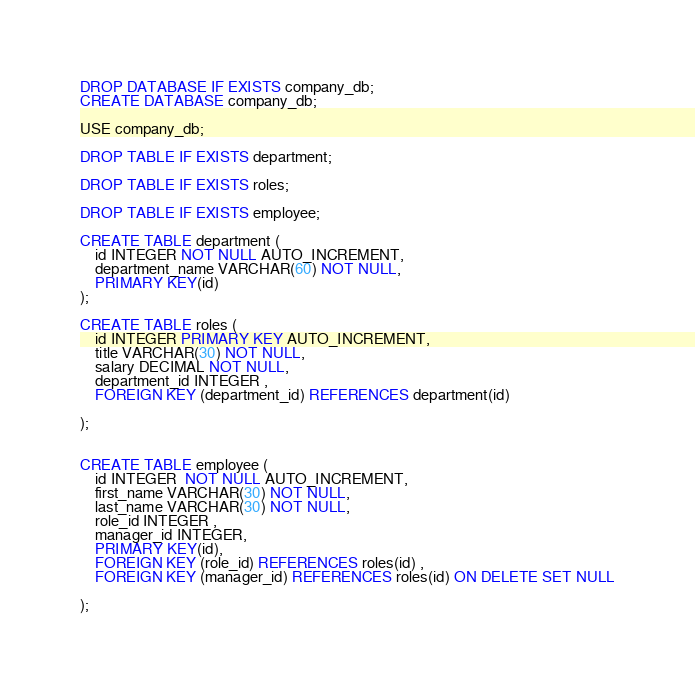Convert code to text. <code><loc_0><loc_0><loc_500><loc_500><_SQL_>DROP DATABASE IF EXISTS company_db;
CREATE DATABASE company_db;

USE company_db;

DROP TABLE IF EXISTS department;

DROP TABLE IF EXISTS roles;

DROP TABLE IF EXISTS employee;

CREATE TABLE department (
    id INTEGER NOT NULL AUTO_INCREMENT,
    department_name VARCHAR(60) NOT NULL,
    PRIMARY KEY(id)
);

CREATE TABLE roles (
    id INTEGER PRIMARY KEY AUTO_INCREMENT,
    title VARCHAR(30) NOT NULL,
    salary DECIMAL NOT NULL,
    department_id INTEGER ,
    FOREIGN KEY (department_id) REFERENCES department(id) 
    
);


CREATE TABLE employee (
    id INTEGER  NOT NULL AUTO_INCREMENT,
    first_name VARCHAR(30) NOT NULL,
    last_name VARCHAR(30) NOT NULL,
    role_id INTEGER ,
    manager_id INTEGER,
    PRIMARY KEY(id),
    FOREIGN KEY (role_id) REFERENCES roles(id) ,
    FOREIGN KEY (manager_id) REFERENCES roles(id) ON DELETE SET NULL
    
);




</code> 